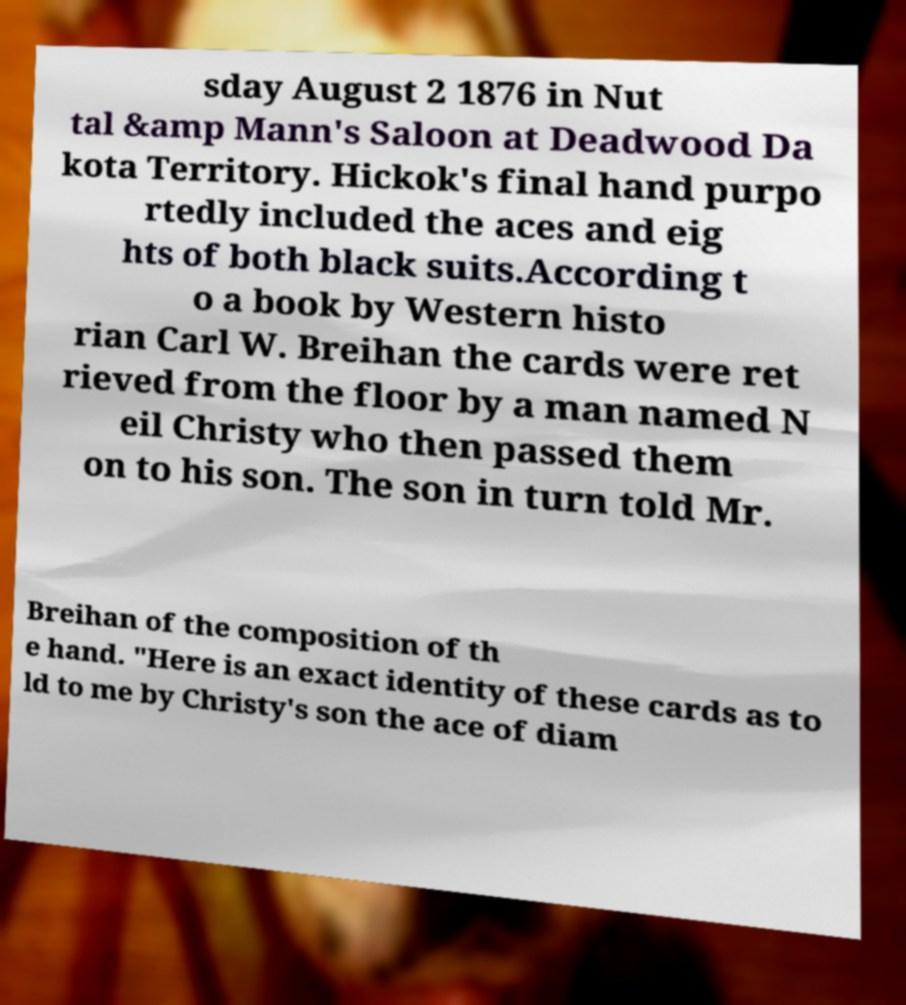For documentation purposes, I need the text within this image transcribed. Could you provide that? sday August 2 1876 in Nut tal &amp Mann's Saloon at Deadwood Da kota Territory. Hickok's final hand purpo rtedly included the aces and eig hts of both black suits.According t o a book by Western histo rian Carl W. Breihan the cards were ret rieved from the floor by a man named N eil Christy who then passed them on to his son. The son in turn told Mr. Breihan of the composition of th e hand. "Here is an exact identity of these cards as to ld to me by Christy's son the ace of diam 